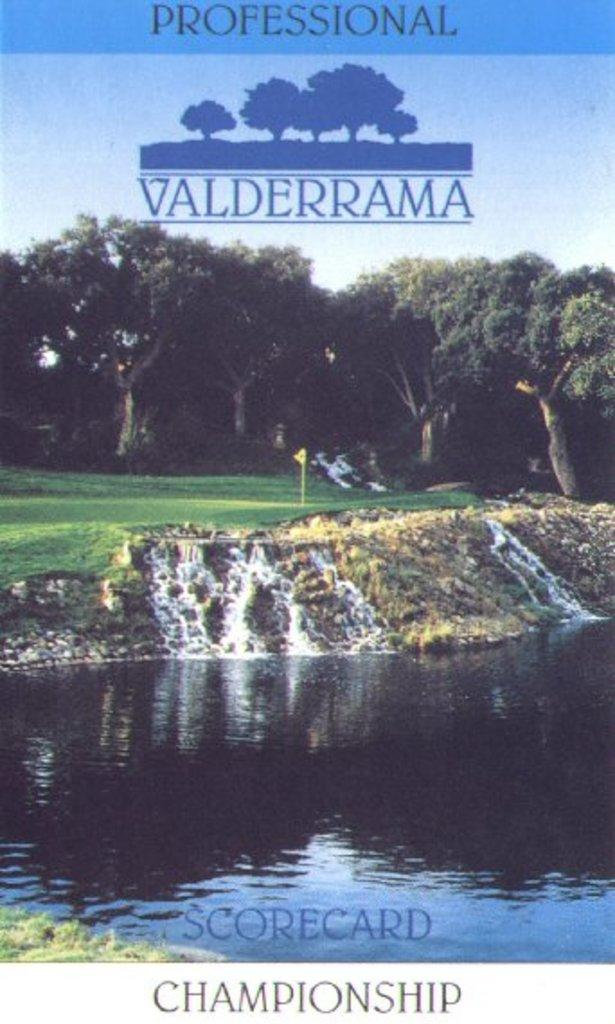<image>
Write a terse but informative summary of the picture. A poster for a golf course called Professional Valderrama. 